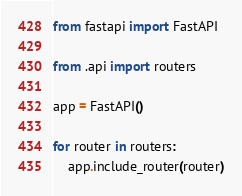<code> <loc_0><loc_0><loc_500><loc_500><_Python_>from fastapi import FastAPI

from .api import routers

app = FastAPI()

for router in routers:
    app.include_router(router)
</code> 